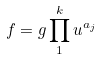Convert formula to latex. <formula><loc_0><loc_0><loc_500><loc_500>f = g \prod _ { 1 } ^ { k } u ^ { a _ { j } }</formula> 